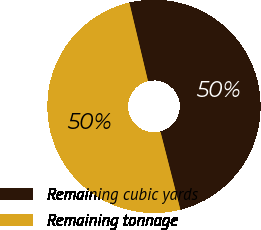Convert chart to OTSL. <chart><loc_0><loc_0><loc_500><loc_500><pie_chart><fcel>Remaining cubic yards<fcel>Remaining tonnage<nl><fcel>49.73%<fcel>50.27%<nl></chart> 